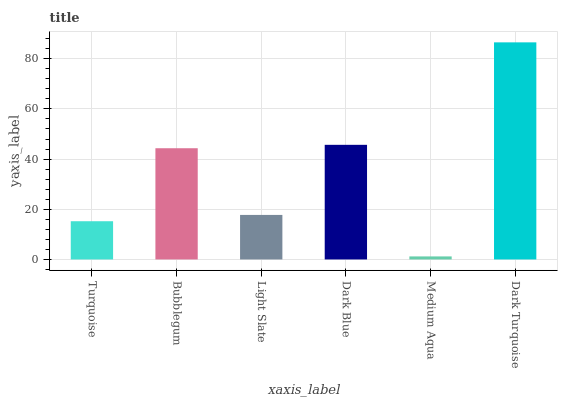Is Medium Aqua the minimum?
Answer yes or no. Yes. Is Dark Turquoise the maximum?
Answer yes or no. Yes. Is Bubblegum the minimum?
Answer yes or no. No. Is Bubblegum the maximum?
Answer yes or no. No. Is Bubblegum greater than Turquoise?
Answer yes or no. Yes. Is Turquoise less than Bubblegum?
Answer yes or no. Yes. Is Turquoise greater than Bubblegum?
Answer yes or no. No. Is Bubblegum less than Turquoise?
Answer yes or no. No. Is Bubblegum the high median?
Answer yes or no. Yes. Is Light Slate the low median?
Answer yes or no. Yes. Is Medium Aqua the high median?
Answer yes or no. No. Is Bubblegum the low median?
Answer yes or no. No. 